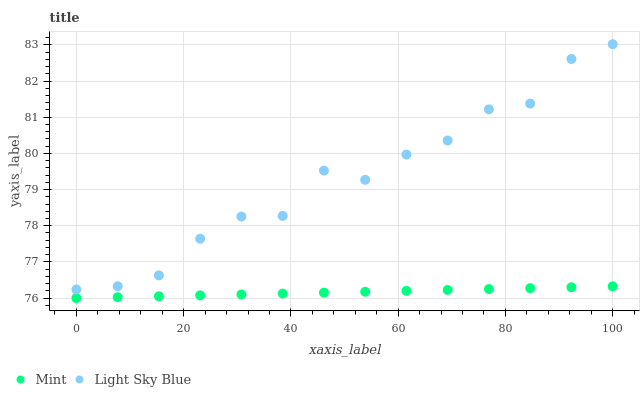Does Mint have the minimum area under the curve?
Answer yes or no. Yes. Does Light Sky Blue have the maximum area under the curve?
Answer yes or no. Yes. Does Mint have the maximum area under the curve?
Answer yes or no. No. Is Mint the smoothest?
Answer yes or no. Yes. Is Light Sky Blue the roughest?
Answer yes or no. Yes. Is Mint the roughest?
Answer yes or no. No. Does Mint have the lowest value?
Answer yes or no. Yes. Does Light Sky Blue have the highest value?
Answer yes or no. Yes. Does Mint have the highest value?
Answer yes or no. No. Is Mint less than Light Sky Blue?
Answer yes or no. Yes. Is Light Sky Blue greater than Mint?
Answer yes or no. Yes. Does Mint intersect Light Sky Blue?
Answer yes or no. No. 